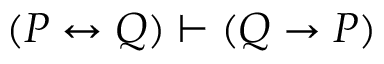Convert formula to latex. <formula><loc_0><loc_0><loc_500><loc_500>( P \leftrightarrow Q ) \vdash ( Q \to P )</formula> 